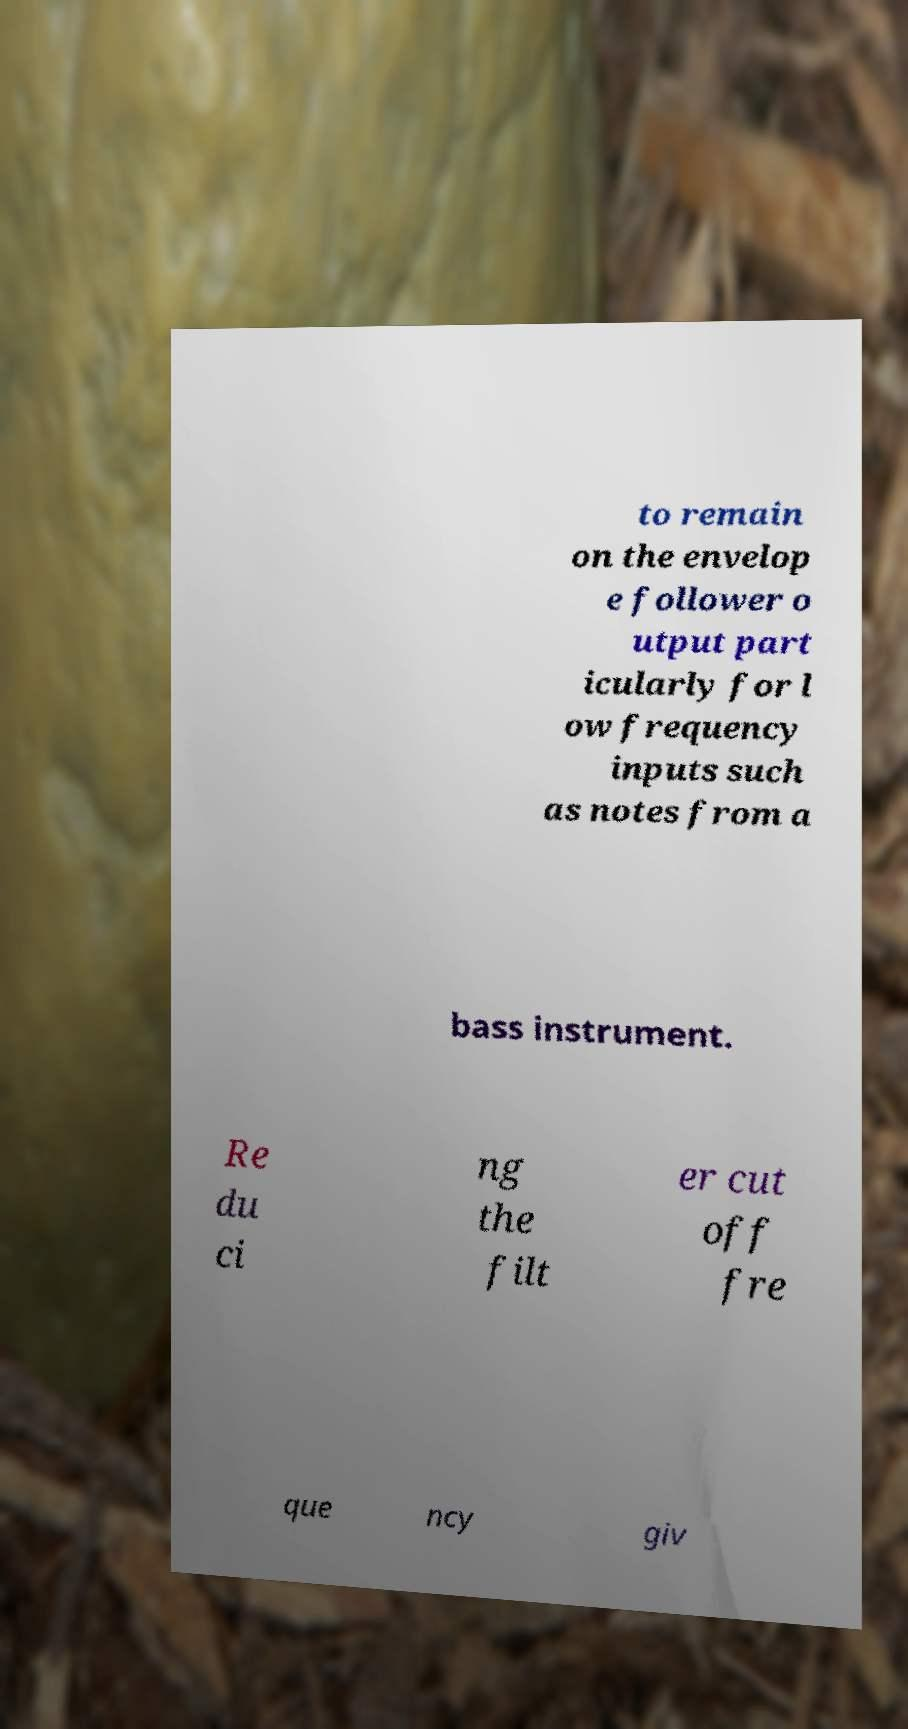Can you accurately transcribe the text from the provided image for me? to remain on the envelop e follower o utput part icularly for l ow frequency inputs such as notes from a bass instrument. Re du ci ng the filt er cut off fre que ncy giv 